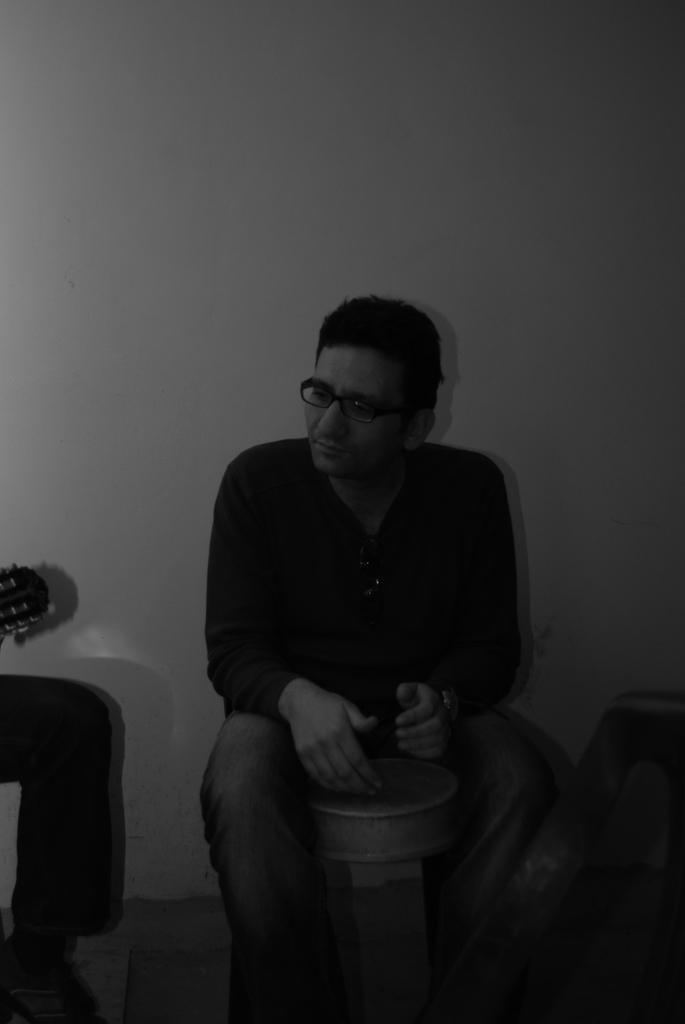Describe this image in one or two sentences. In this image we can see a man sitting. On the left we can see a person's leg. In the background there is a wall. 